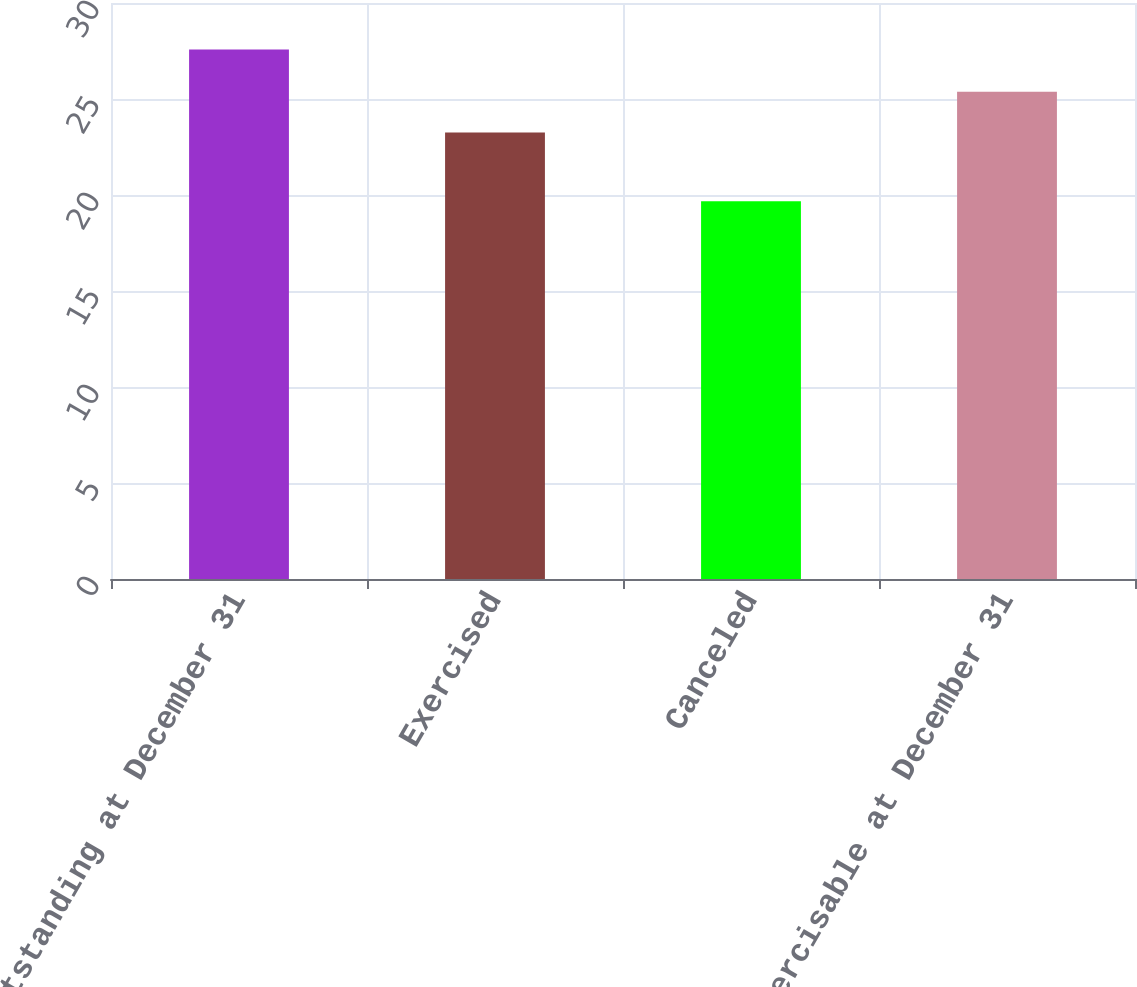Convert chart. <chart><loc_0><loc_0><loc_500><loc_500><bar_chart><fcel>Outstanding at December 31<fcel>Exercised<fcel>Canceled<fcel>Exercisable at December 31<nl><fcel>27.58<fcel>23.26<fcel>19.67<fcel>25.38<nl></chart> 